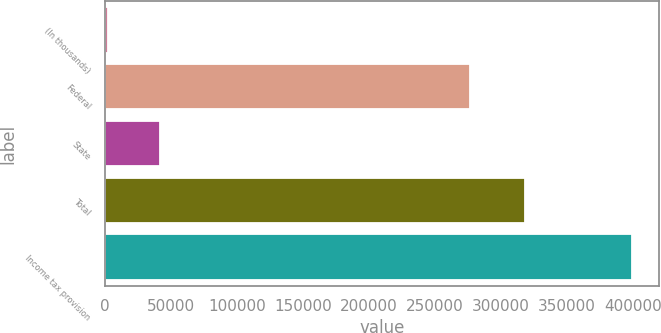Convert chart. <chart><loc_0><loc_0><loc_500><loc_500><bar_chart><fcel>(In thousands)<fcel>Federal<fcel>State<fcel>Total<fcel>Income tax provision<nl><fcel>2018<fcel>276597<fcel>41892<fcel>318489<fcel>399496<nl></chart> 